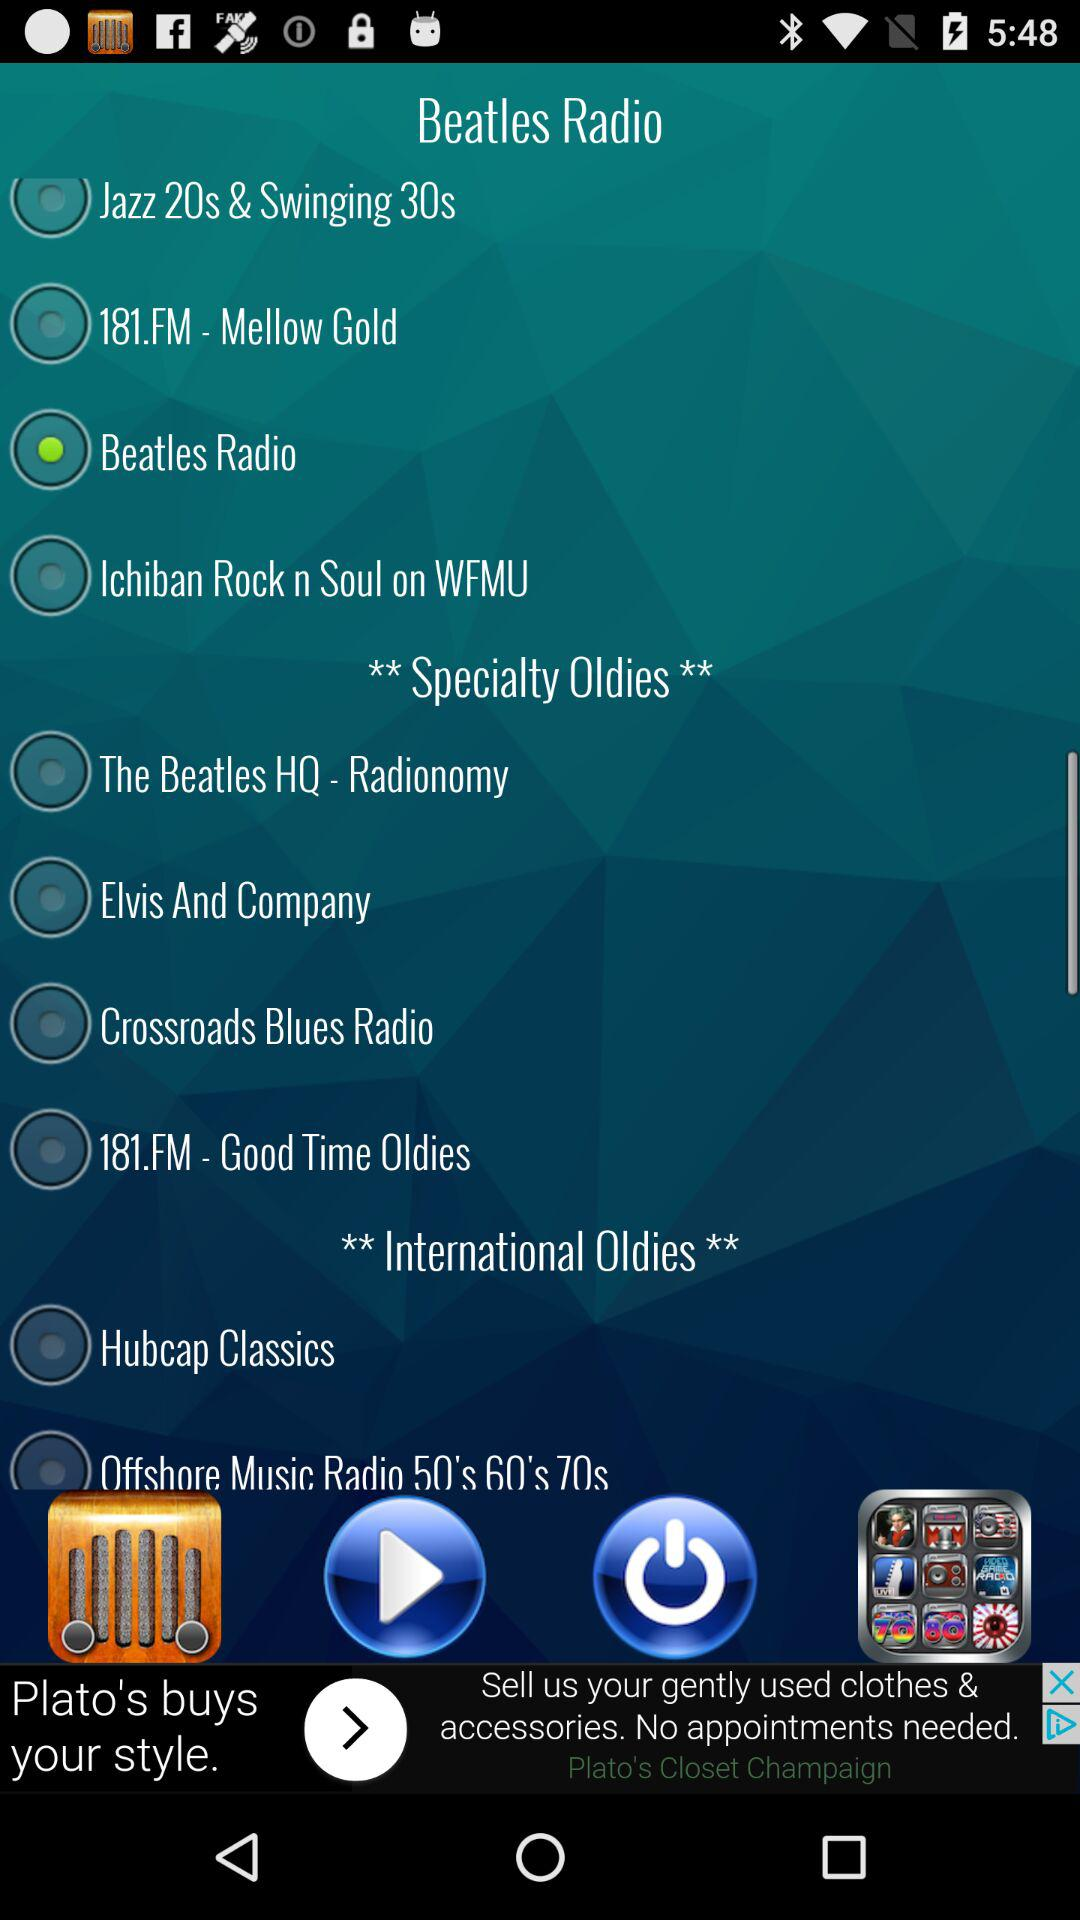Is "Elvis And Company" currently selected or not? "Elvis And Company" is not currently selected on the screen. In the image, you can see that selections are indicated by a green circle next to the station name. There is no green circle next to 'Elvis And Company.' 